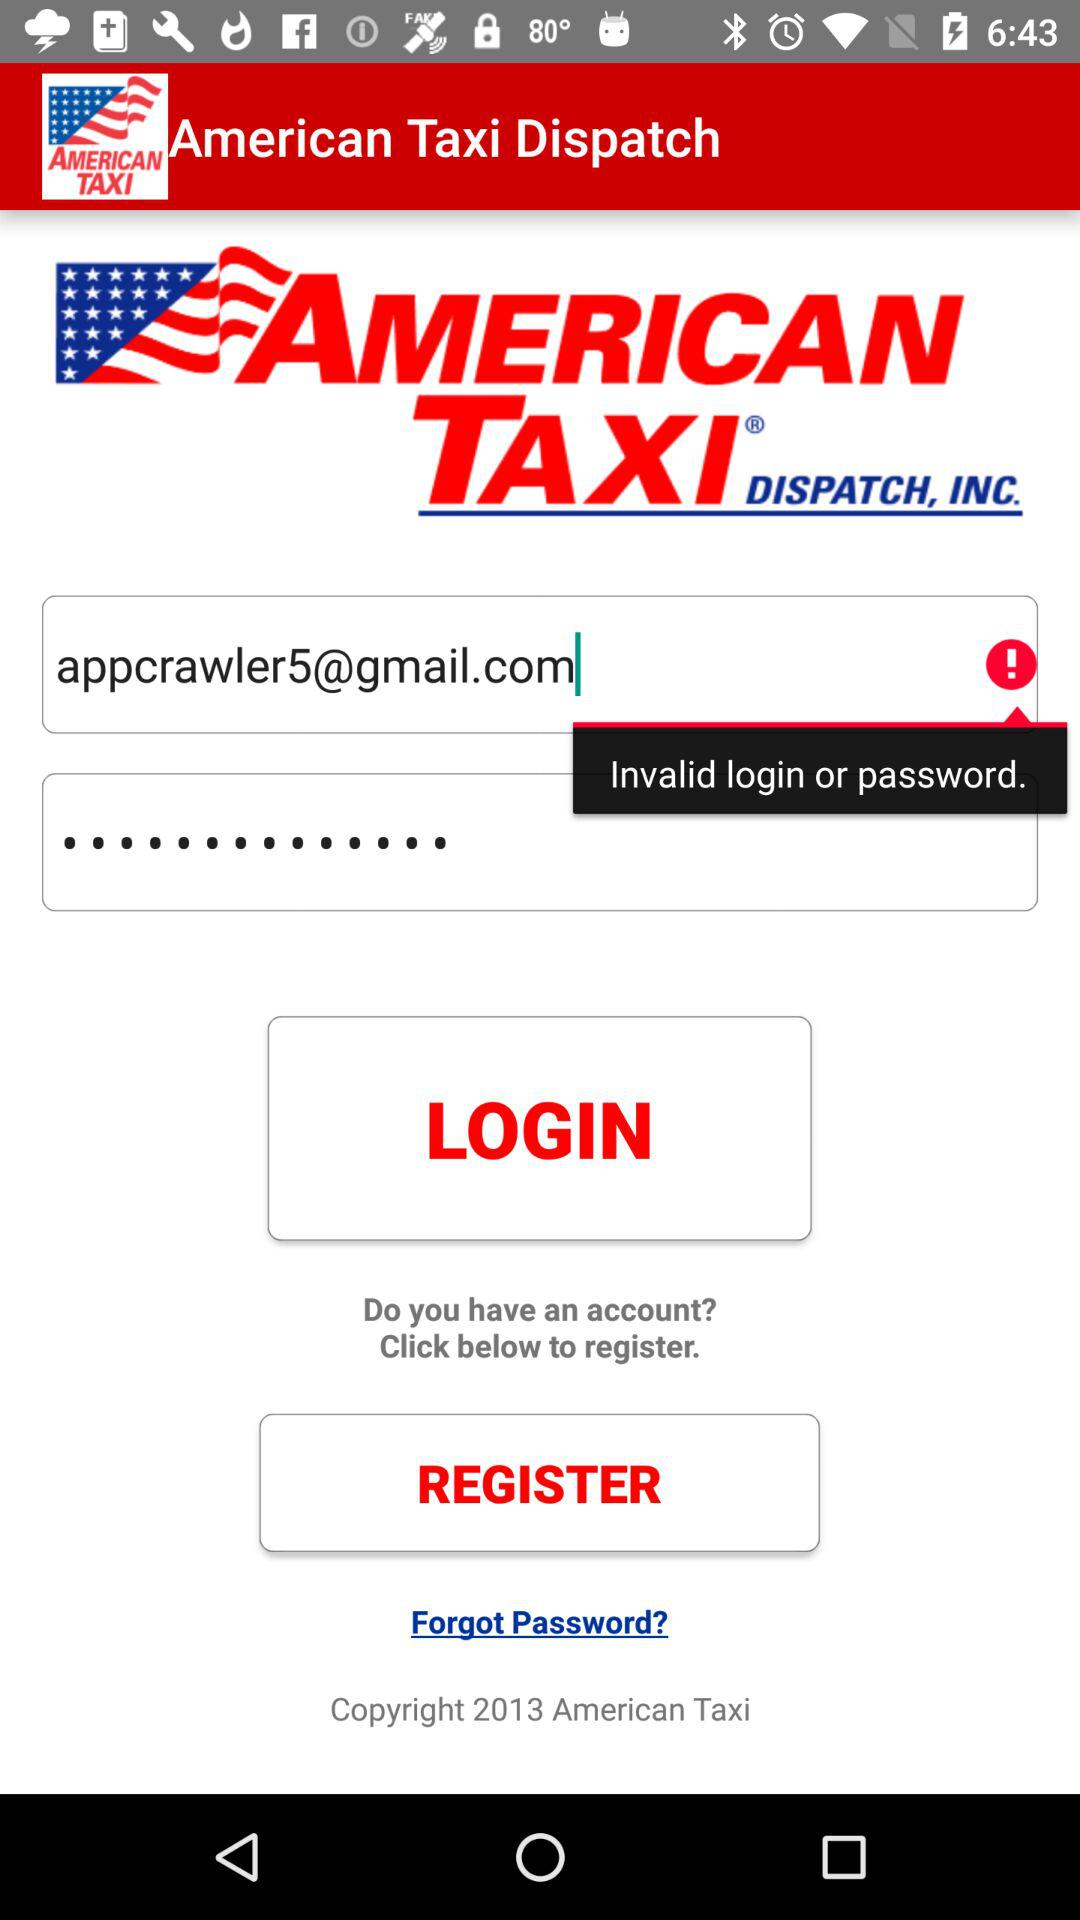What is the email address of the user? The email address of the user is "appcrawler5@gmail.com". 